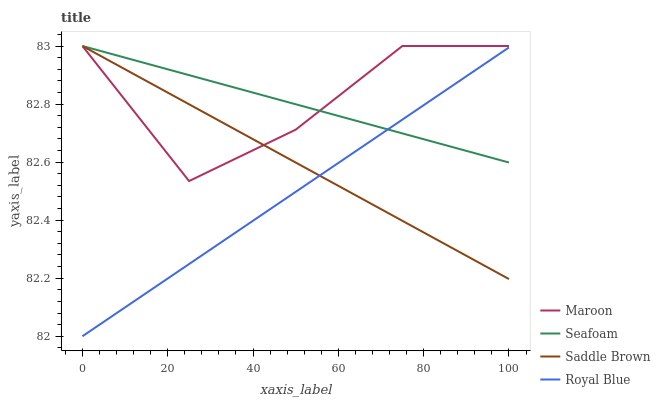Does Royal Blue have the minimum area under the curve?
Answer yes or no. Yes. Does Maroon have the maximum area under the curve?
Answer yes or no. Yes. Does Seafoam have the minimum area under the curve?
Answer yes or no. No. Does Seafoam have the maximum area under the curve?
Answer yes or no. No. Is Seafoam the smoothest?
Answer yes or no. Yes. Is Maroon the roughest?
Answer yes or no. Yes. Is Maroon the smoothest?
Answer yes or no. No. Is Seafoam the roughest?
Answer yes or no. No. Does Royal Blue have the lowest value?
Answer yes or no. Yes. Does Maroon have the lowest value?
Answer yes or no. No. Does Saddle Brown have the highest value?
Answer yes or no. Yes. Is Royal Blue less than Maroon?
Answer yes or no. Yes. Is Maroon greater than Royal Blue?
Answer yes or no. Yes. Does Seafoam intersect Royal Blue?
Answer yes or no. Yes. Is Seafoam less than Royal Blue?
Answer yes or no. No. Is Seafoam greater than Royal Blue?
Answer yes or no. No. Does Royal Blue intersect Maroon?
Answer yes or no. No. 